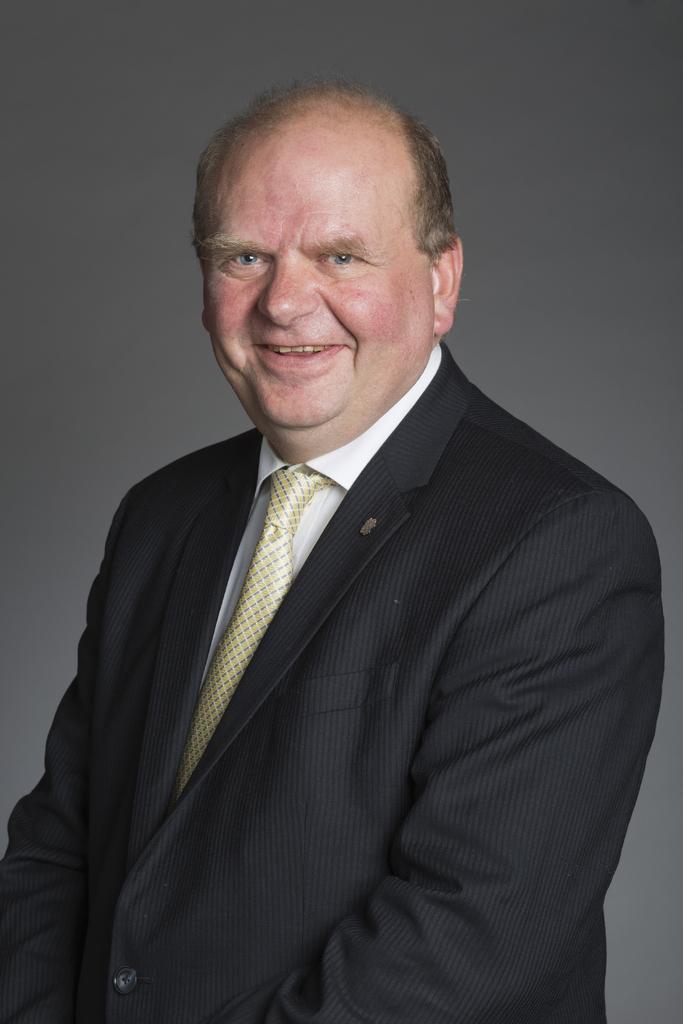How would you summarize this image in a sentence or two? In this image I can see the person wearing the black blazer, white shirt and the cream color tie. The person is smiling. And there is a grey color background. 